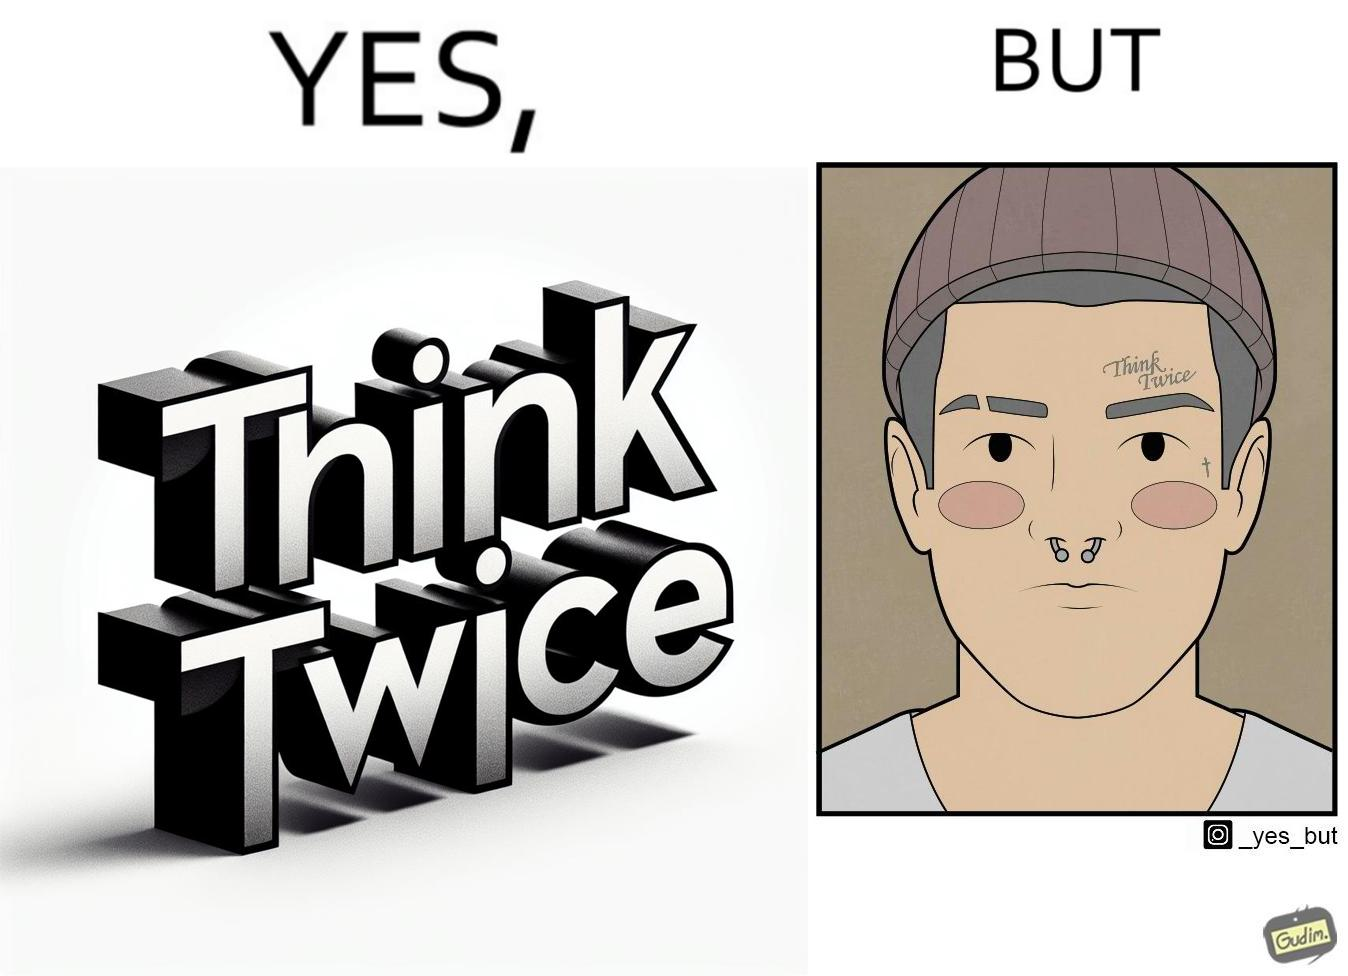What does this image depict? The image is funny because even thought the tattoo on the face of the man says "think twice", the man did not think twice before getting the tattoo on his forehead. 